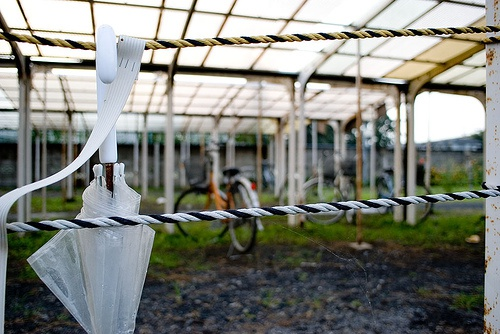Describe the objects in this image and their specific colors. I can see umbrella in white, darkgray, lavender, gray, and lightgray tones, bicycle in white, darkgreen, black, gray, and darkgray tones, and bicycle in white, gray, darkgreen, and black tones in this image. 